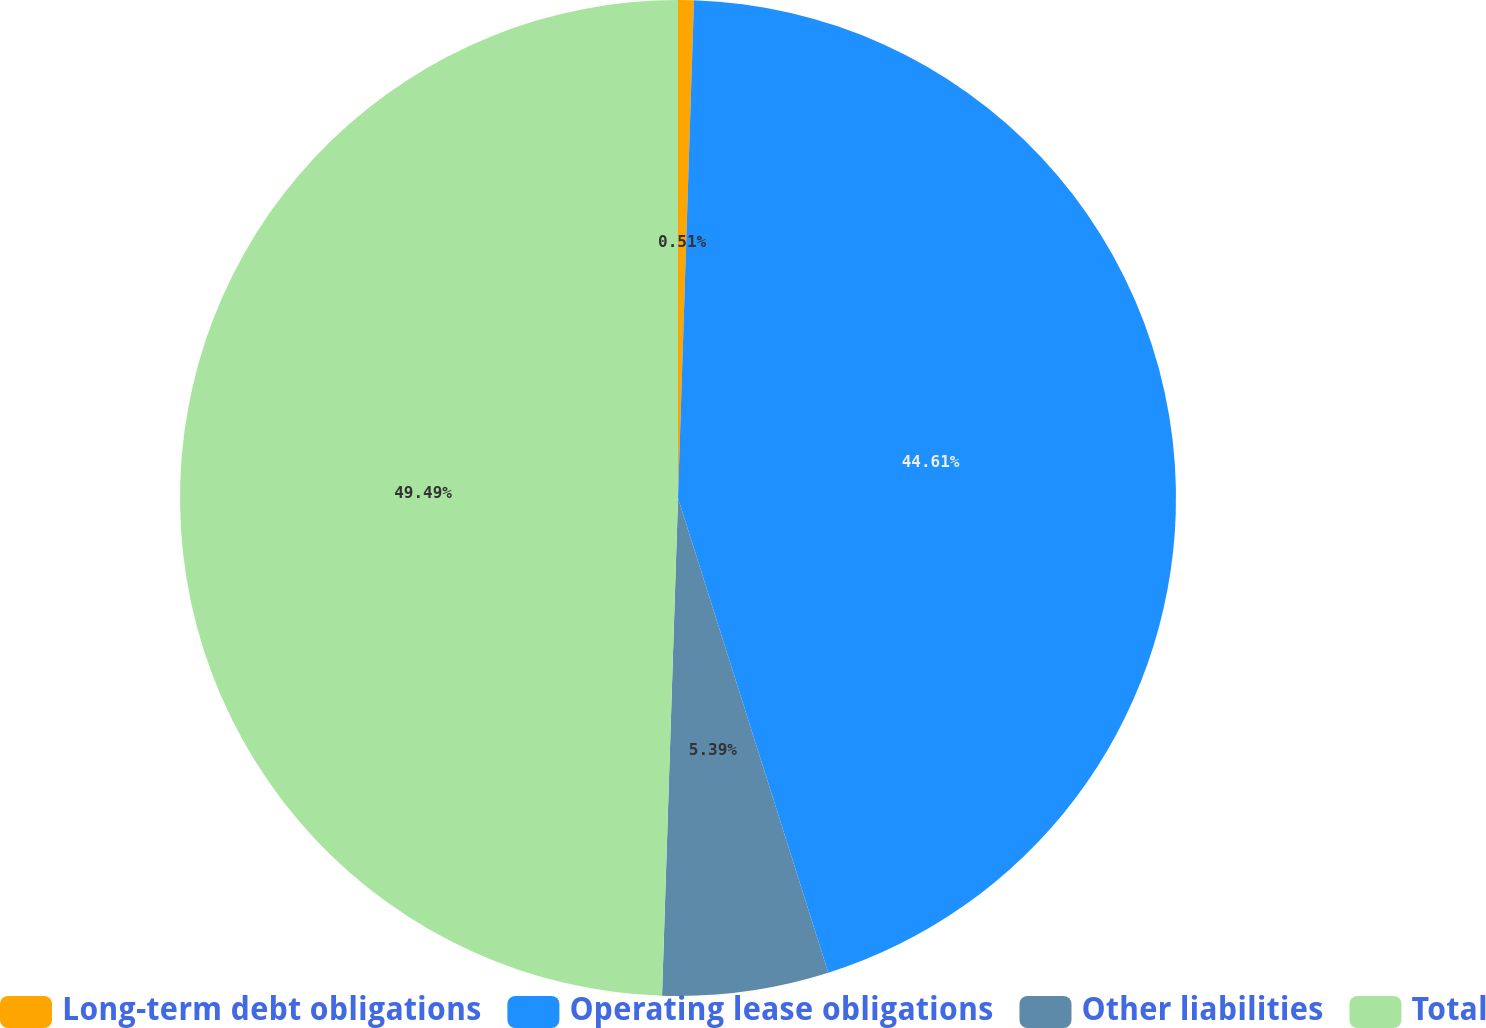Convert chart to OTSL. <chart><loc_0><loc_0><loc_500><loc_500><pie_chart><fcel>Long-term debt obligations<fcel>Operating lease obligations<fcel>Other liabilities<fcel>Total<nl><fcel>0.51%<fcel>44.61%<fcel>5.39%<fcel>49.49%<nl></chart> 